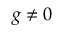Convert formula to latex. <formula><loc_0><loc_0><loc_500><loc_500>g \neq 0</formula> 